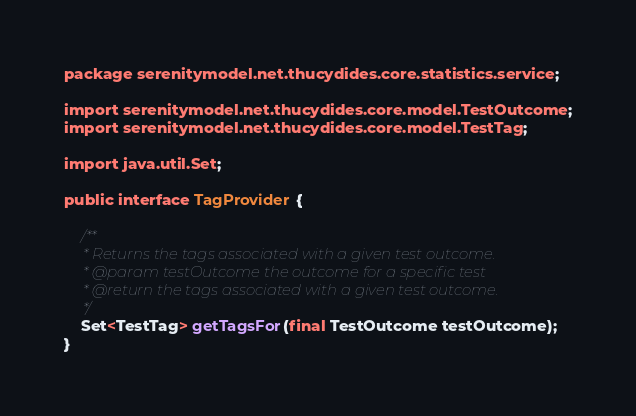<code> <loc_0><loc_0><loc_500><loc_500><_Java_>package serenitymodel.net.thucydides.core.statistics.service;

import serenitymodel.net.thucydides.core.model.TestOutcome;
import serenitymodel.net.thucydides.core.model.TestTag;

import java.util.Set;

public interface TagProvider {

    /**
     * Returns the tags associated with a given test outcome.
     * @param testOutcome the outcome for a specific test
     * @return the tags associated with a given test outcome.
     */
    Set<TestTag> getTagsFor(final TestOutcome testOutcome);
}
</code> 